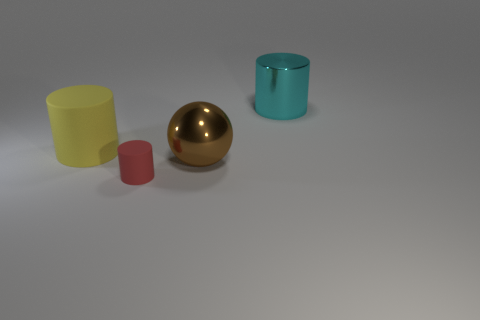Add 4 small red objects. How many objects exist? 8 Subtract all balls. How many objects are left? 3 Add 2 cylinders. How many cylinders are left? 5 Add 1 cylinders. How many cylinders exist? 4 Subtract 1 cyan cylinders. How many objects are left? 3 Subtract all small gray cylinders. Subtract all yellow rubber cylinders. How many objects are left? 3 